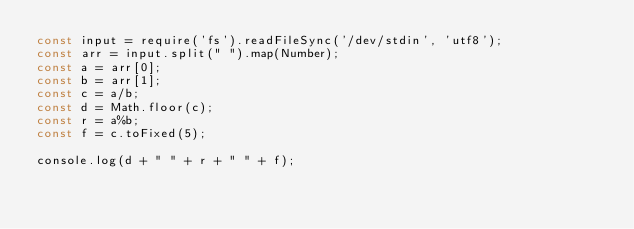<code> <loc_0><loc_0><loc_500><loc_500><_JavaScript_>const input = require('fs').readFileSync('/dev/stdin', 'utf8');
const arr = input.split(" ").map(Number);
const a = arr[0];
const b = arr[1];
const c = a/b;
const d = Math.floor(c);
const r = a%b;
const f = c.toFixed(5);

console.log(d + " " + r + " " + f);

</code> 